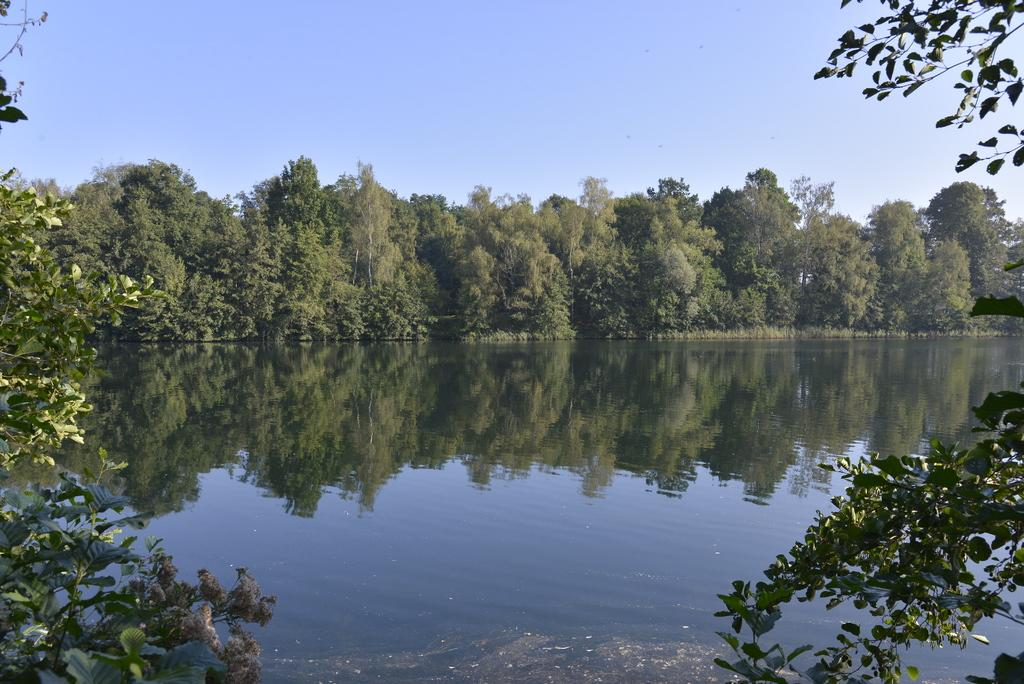What type of vegetation can be seen in the image? There are trees in the image. What natural element is visible besides the trees? There is water visible in the image. What part of the natural environment is visible in the image? The sky is visible in the image. What type of caption is written on the trees in the image? There is no caption written on the trees in the image; they are simply trees. 